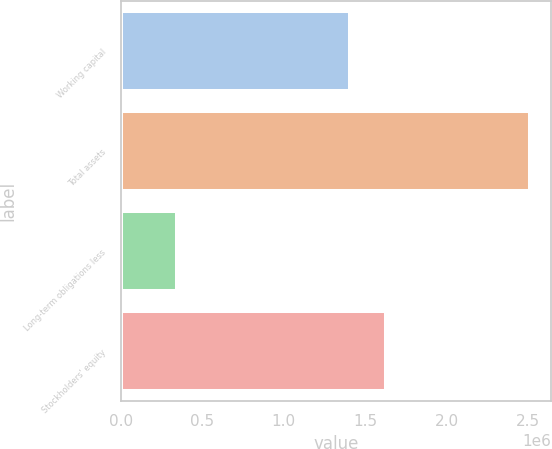Convert chart to OTSL. <chart><loc_0><loc_0><loc_500><loc_500><bar_chart><fcel>Working capital<fcel>Total assets<fcel>Long-term obligations less<fcel>Stockholders' equity<nl><fcel>1.40758e+06<fcel>2.51631e+06<fcel>340672<fcel>1.62514e+06<nl></chart> 